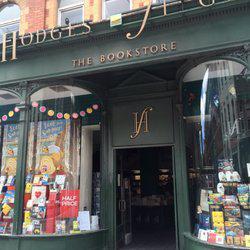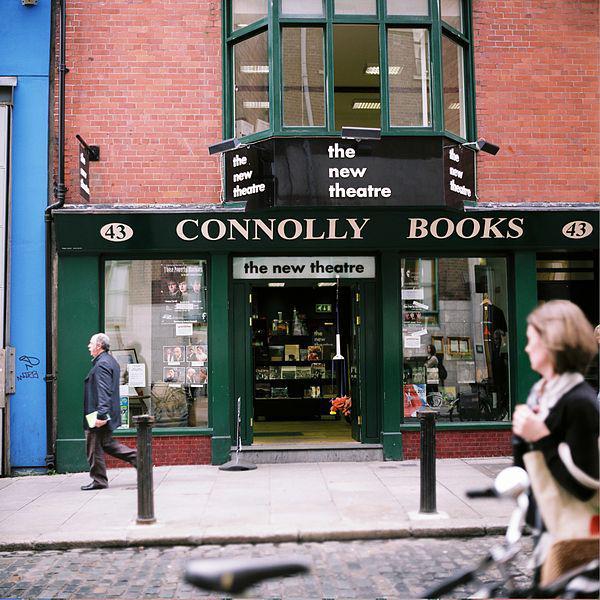The first image is the image on the left, the second image is the image on the right. Evaluate the accuracy of this statement regarding the images: "People are walking past the shop in the image on the right.". Is it true? Answer yes or no. Yes. The first image is the image on the left, the second image is the image on the right. For the images displayed, is the sentence "Left and right images show the same store exterior, and each storefront has a row of windows with tops that are at least slightly arched." factually correct? Answer yes or no. No. 